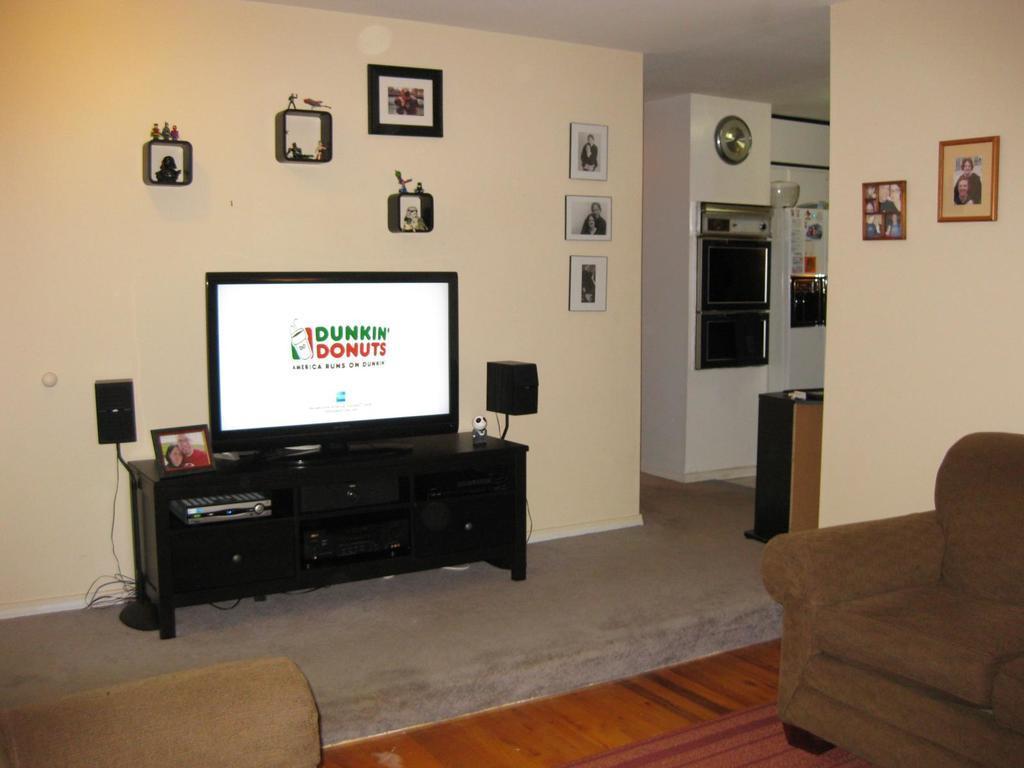In one or two sentences, can you explain what this image depicts? In this room at the wall there is a table. On it TV,frame are there. On the wall we can see frames,clock and here we have 2 chairs. 